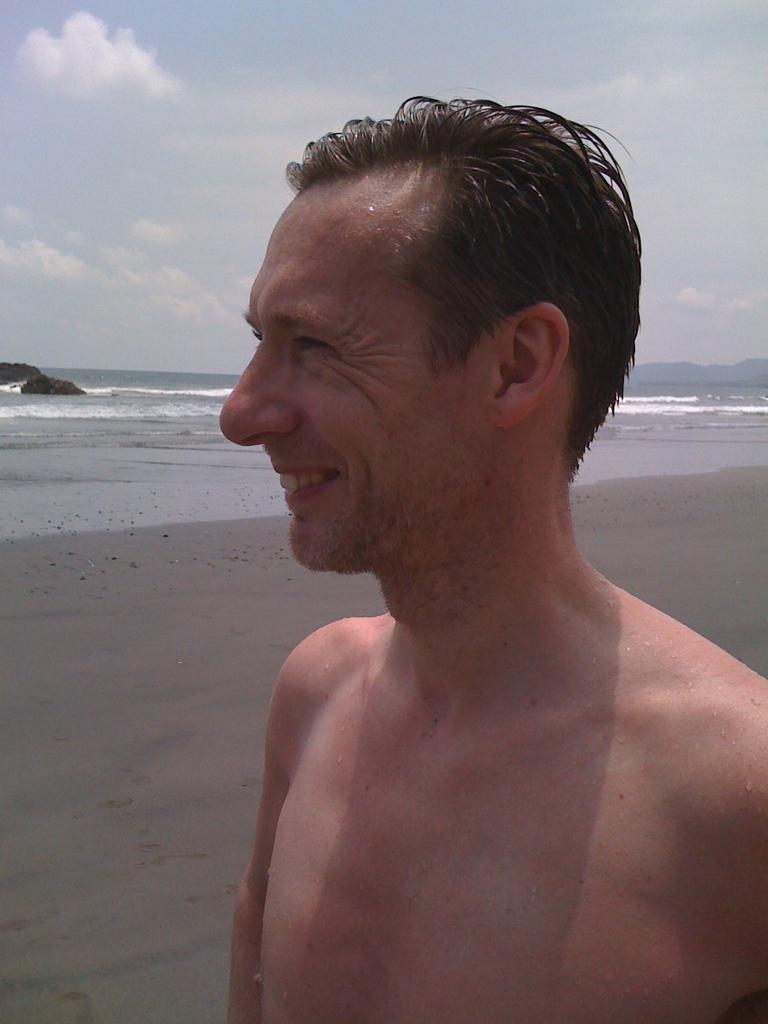Could you give a brief overview of what you see in this image? In this image we can see a man standing on the seashore, sea, rocks and sky with clouds. 